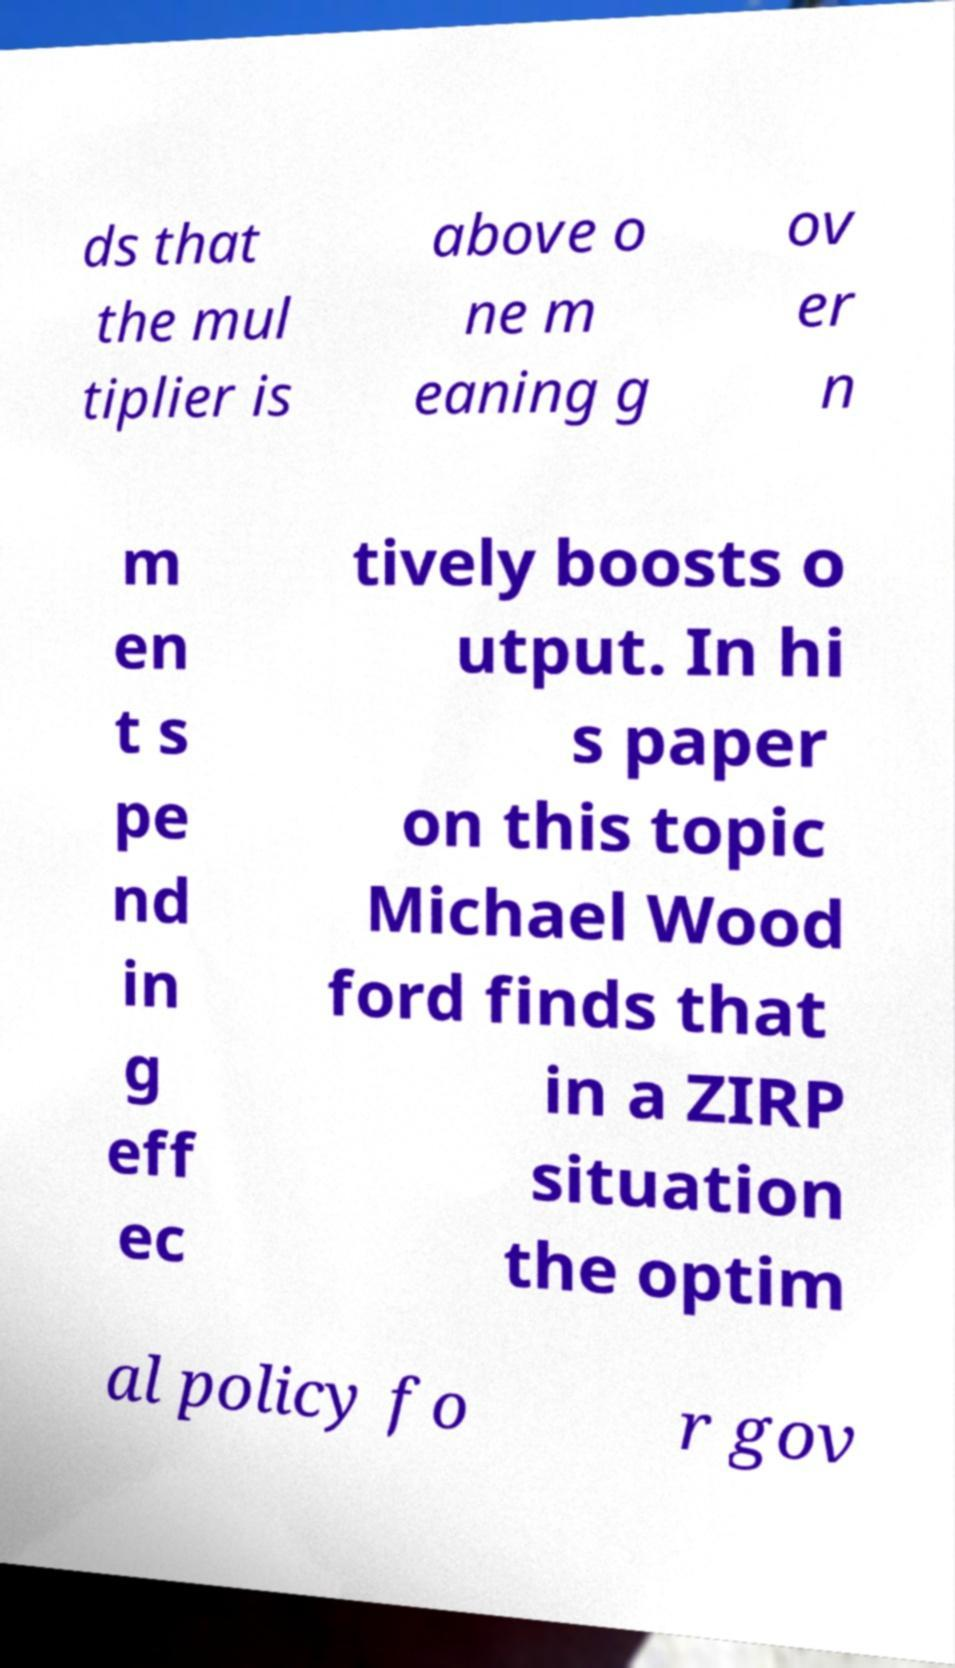Please identify and transcribe the text found in this image. ds that the mul tiplier is above o ne m eaning g ov er n m en t s pe nd in g eff ec tively boosts o utput. In hi s paper on this topic Michael Wood ford finds that in a ZIRP situation the optim al policy fo r gov 